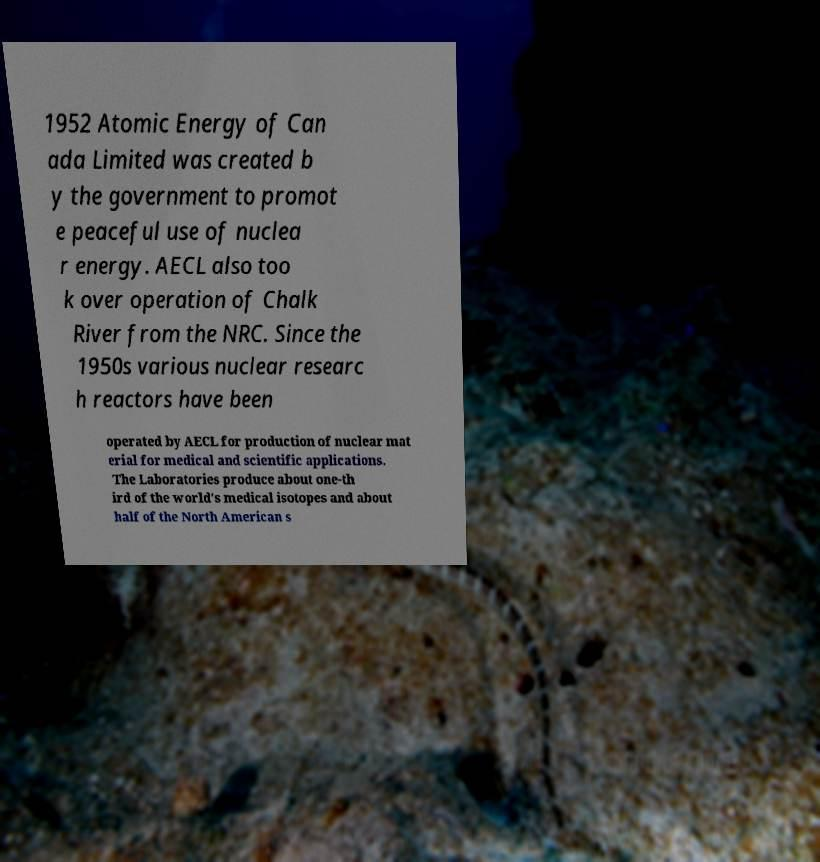Could you assist in decoding the text presented in this image and type it out clearly? 1952 Atomic Energy of Can ada Limited was created b y the government to promot e peaceful use of nuclea r energy. AECL also too k over operation of Chalk River from the NRC. Since the 1950s various nuclear researc h reactors have been operated by AECL for production of nuclear mat erial for medical and scientific applications. The Laboratories produce about one-th ird of the world's medical isotopes and about half of the North American s 